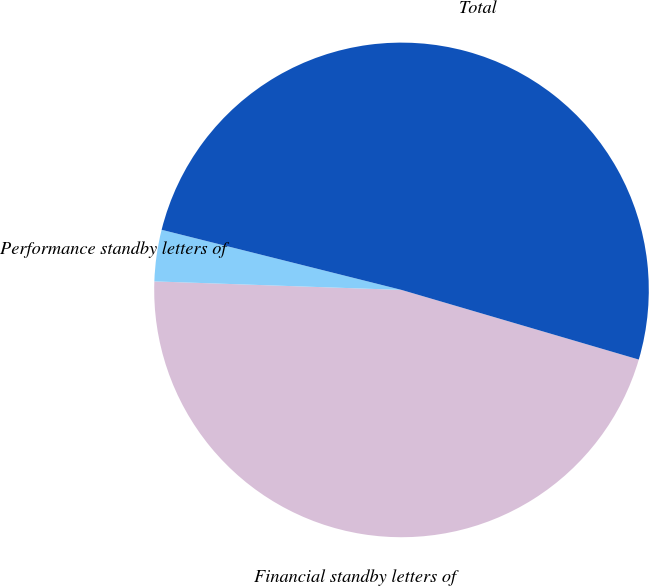Convert chart to OTSL. <chart><loc_0><loc_0><loc_500><loc_500><pie_chart><fcel>Financial standby letters of<fcel>Performance standby letters of<fcel>Total<nl><fcel>46.0%<fcel>3.36%<fcel>50.63%<nl></chart> 